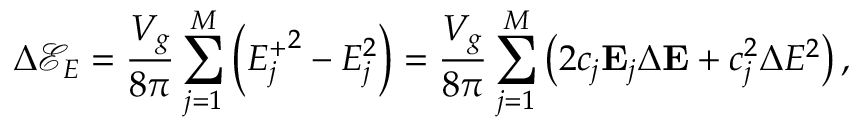<formula> <loc_0><loc_0><loc_500><loc_500>\Delta \mathcal { E } _ { E } = \frac { V _ { g } } { 8 \pi } \sum _ { j = 1 } ^ { M } \left ( { E _ { j } ^ { + } } ^ { 2 } - E _ { j } ^ { 2 } \right ) = \frac { V _ { g } } { 8 \pi } \sum _ { j = 1 } ^ { M } \left ( 2 c _ { j } E _ { j } \Delta E + c _ { j } ^ { 2 } \Delta E ^ { 2 } \right ) ,</formula> 